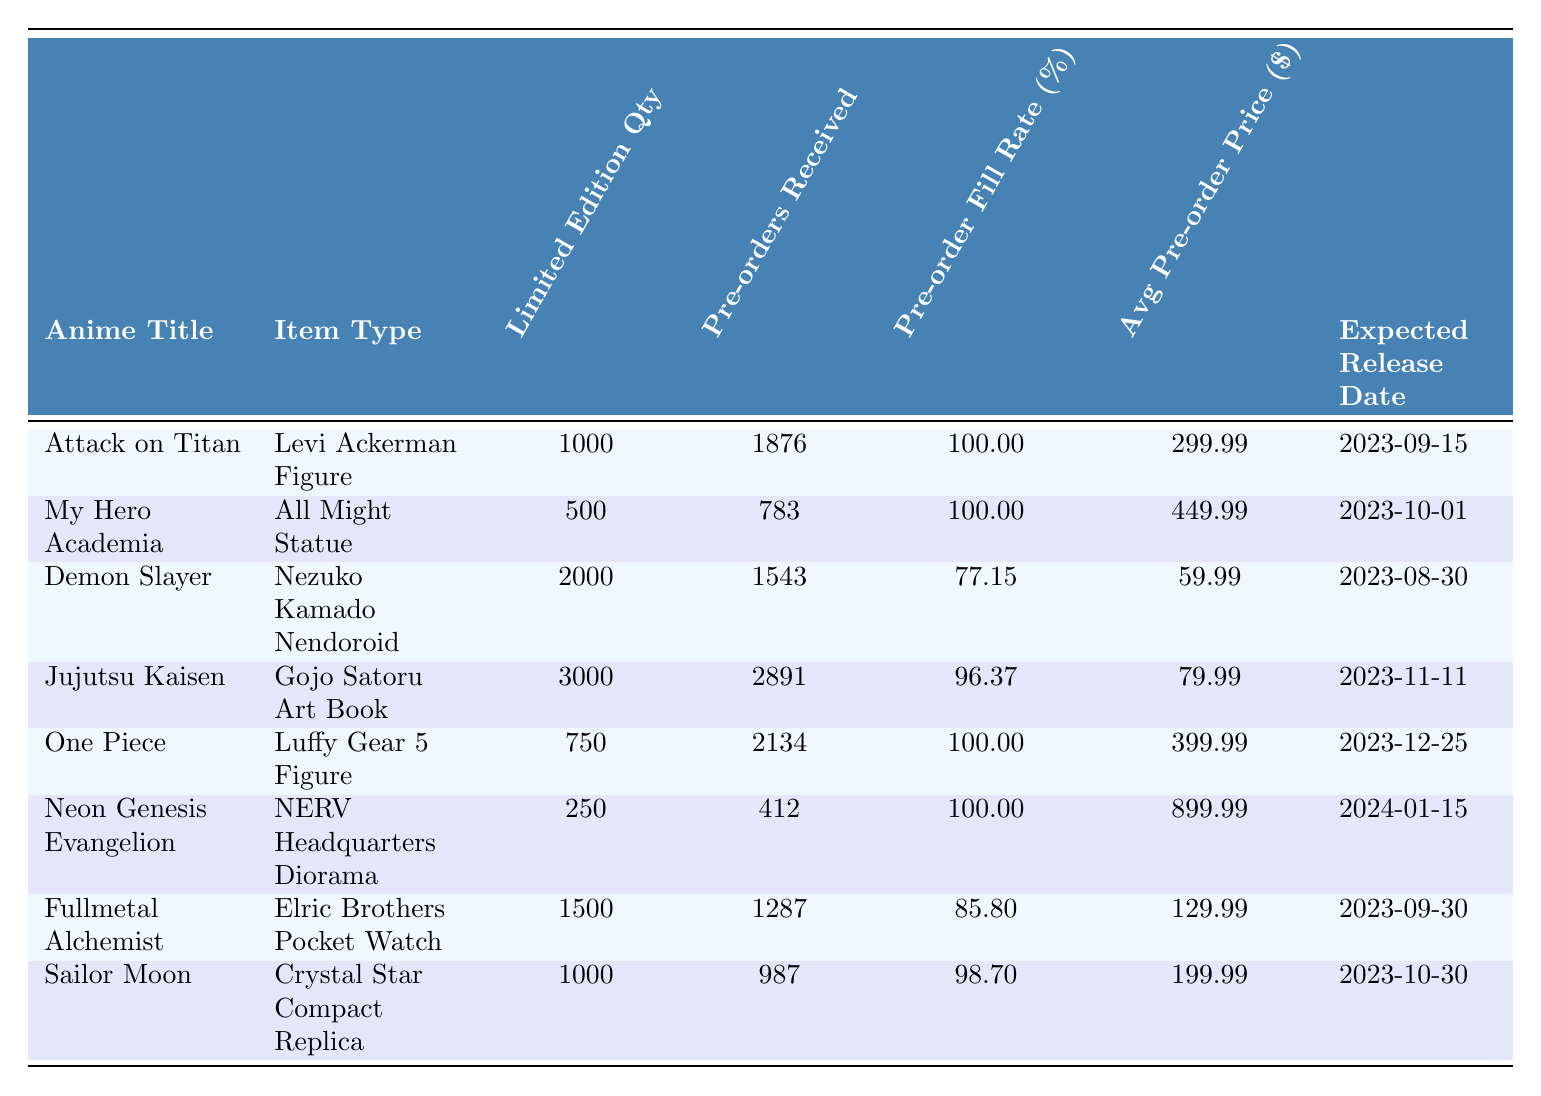What is the pre-order fill rate for the "Neon Genesis Evangelion" item? Looking at the table, the pre-order fill rate for "Neon Genesis Evangelion" is stated in the respective column. It shows a fill rate of 100.00%.
Answer: 100.00% How many pre-orders were received for the "Demon Slayer" collectible? The table lists "Demon Slayer" with 1543 pre-orders received. Therefore, that is the answer.
Answer: 1543 Which item has the highest average pre-order price? Comparing the average pre-order prices in the table, the highest price is for the "NERV Headquarters Diorama" at $899.99.
Answer: $899.99 Is the pre-order fill rate for the "Fullmetal Alchemist" item greater than 80%? The pre-order fill rate for the "Fullmetal Alchemist" item is 85.80%, which is indeed greater than 80%.
Answer: Yes What is the total number of pre-orders received for all items listed in the table? To find this, sum all the pre-orders: 1876 + 783 + 1543 + 2891 + 2134 + 412 + 1287 + 987 = 11810.
Answer: 11810 How many limited edition "One Piece" figures were pre-ordered compared to its quantity? The table shows that 2134 pre-orders were received for the "Luffy Gear 5 Figure," while the limited edition quantity is only 750. Since 2134 exceeds 750, the answer reflects this comparison.
Answer: More pre-orders than quantity Which anime title has the earliest expected release date? The expected release dates can be compared: "Demon Slayer" has the earliest release date of 2023-08-30.
Answer: Demon Slayer What percentage of the limited edition quantity was pre-ordered for "Sailor Moon"? Using the formula (Pre-orders Received / Limited Edition Quantity) * 100, we find (987 / 1000) * 100 = 98.70%, which matches the fill rate listed in the table.
Answer: 98.70% Which item type received more than 2000 pre-orders? According to the table, the "Gojo Satoru Art Book" received 2891 pre-orders, which is greater than 2000.
Answer: Gojo Satoru Art Book How many collectibles have a pre-order fill rate of 100%? By examining the table, we can identify that the items with a fill rate of 100% are "Attack on Titan," "My Hero Academia," "One Piece," and "Neon Genesis Evangelion." There are four items with this rate.
Answer: 4 